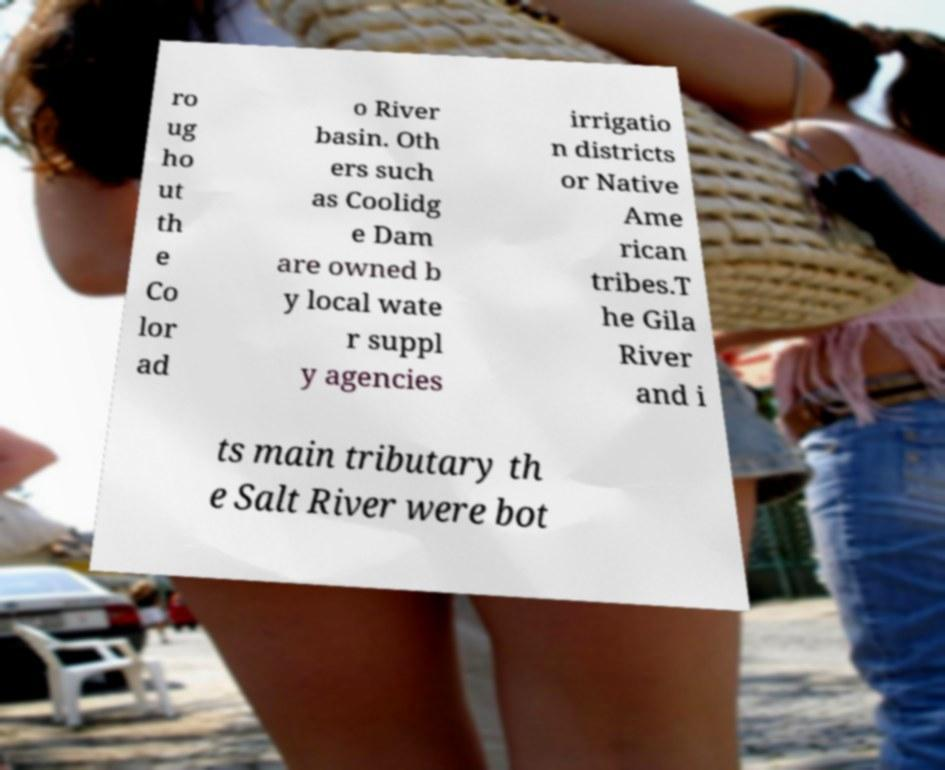There's text embedded in this image that I need extracted. Can you transcribe it verbatim? ro ug ho ut th e Co lor ad o River basin. Oth ers such as Coolidg e Dam are owned b y local wate r suppl y agencies irrigatio n districts or Native Ame rican tribes.T he Gila River and i ts main tributary th e Salt River were bot 